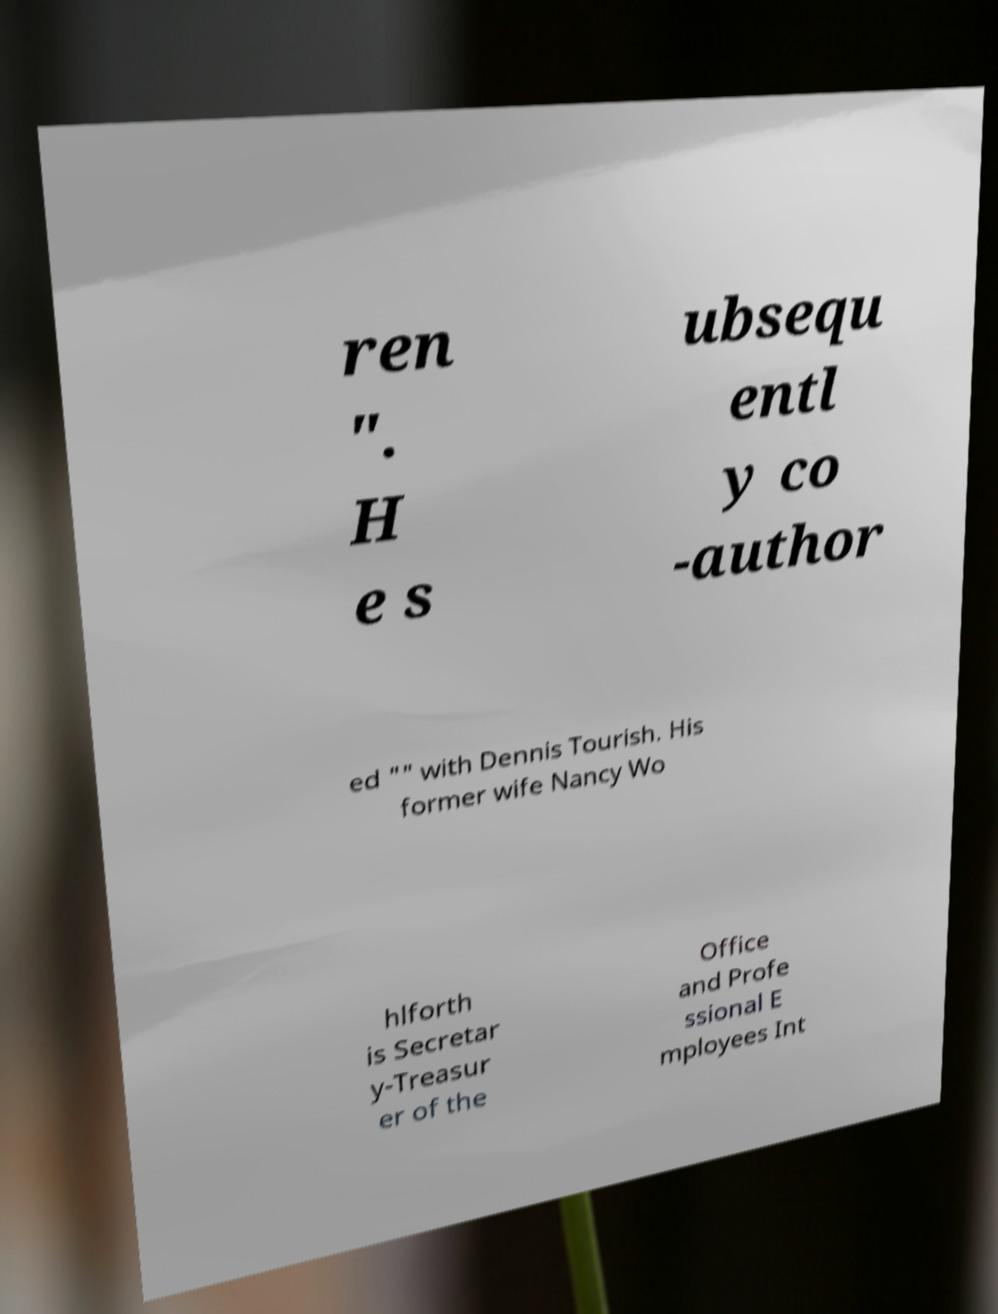Can you accurately transcribe the text from the provided image for me? ren ". H e s ubsequ entl y co -author ed "" with Dennis Tourish. His former wife Nancy Wo hlforth is Secretar y-Treasur er of the Office and Profe ssional E mployees Int 